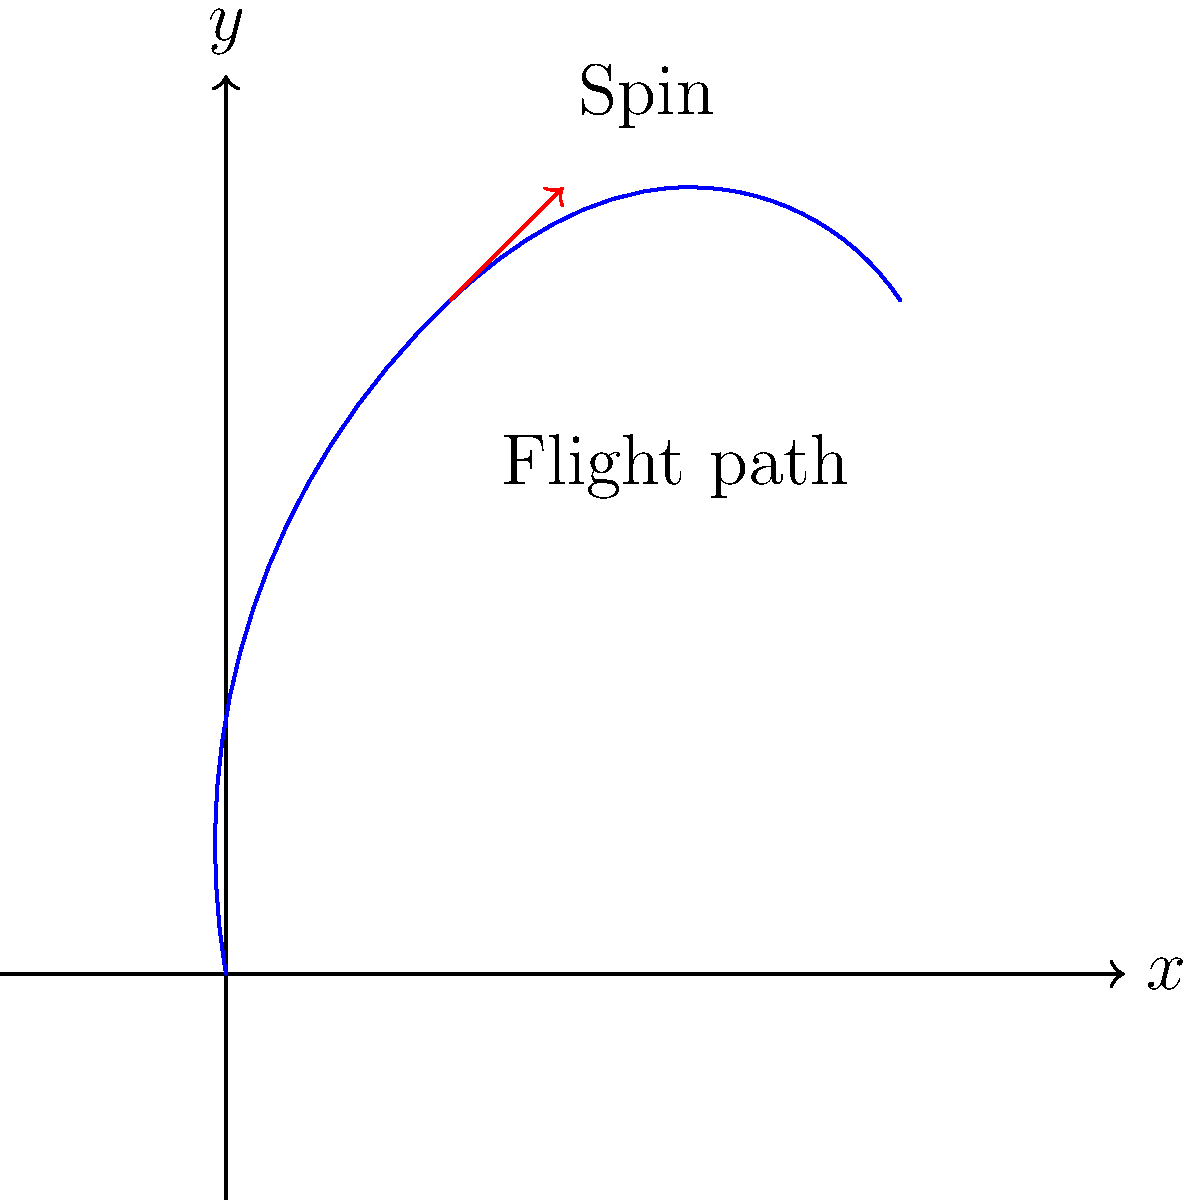In a soccer match, a player kicks a ball with a significant amount of topspin. As the referee, you need to analyze the ball's trajectory to ensure it hasn't been tampered with. Given the flight path shown in the diagram, what physical effect is primarily responsible for the ball's curved trajectory, and how does it relate to the spin direction indicated? To analyze this situation, we need to consider the following steps:

1. Identify the spin direction: The red arrow in the diagram indicates topspin (rotation from top to bottom as the ball moves forward).

2. Recall the Magnus effect: This is the physical phenomenon responsible for the curved trajectory of spinning objects moving through a fluid (in this case, air).

3. Apply the right-hand rule to determine the direction of the force:
   - Curl your fingers in the direction of the spin (top to bottom)
   - Your thumb points in the direction of the Magnus force (upward)

4. Analyze the trajectory:
   - The ball's path curves upward, consistent with the upward Magnus force
   - This upward force opposes gravity, causing the ball to stay in the air longer than it would without spin

5. Relate spin to air pressure:
   - The topspin creates a pressure difference
   - Lower pressure on top of the ball
   - Higher pressure underneath the ball

6. Consider the fairness aspect:
   - This curved trajectory is a natural result of the Magnus effect
   - It does not indicate any tampering with the ball

The Magnus effect, caused by the topspin imparted by the player, is primarily responsible for the ball's curved upward trajectory. This effect is consistent with the laws of physics and does not suggest any unfair play or ball tampering.
Answer: Magnus effect 